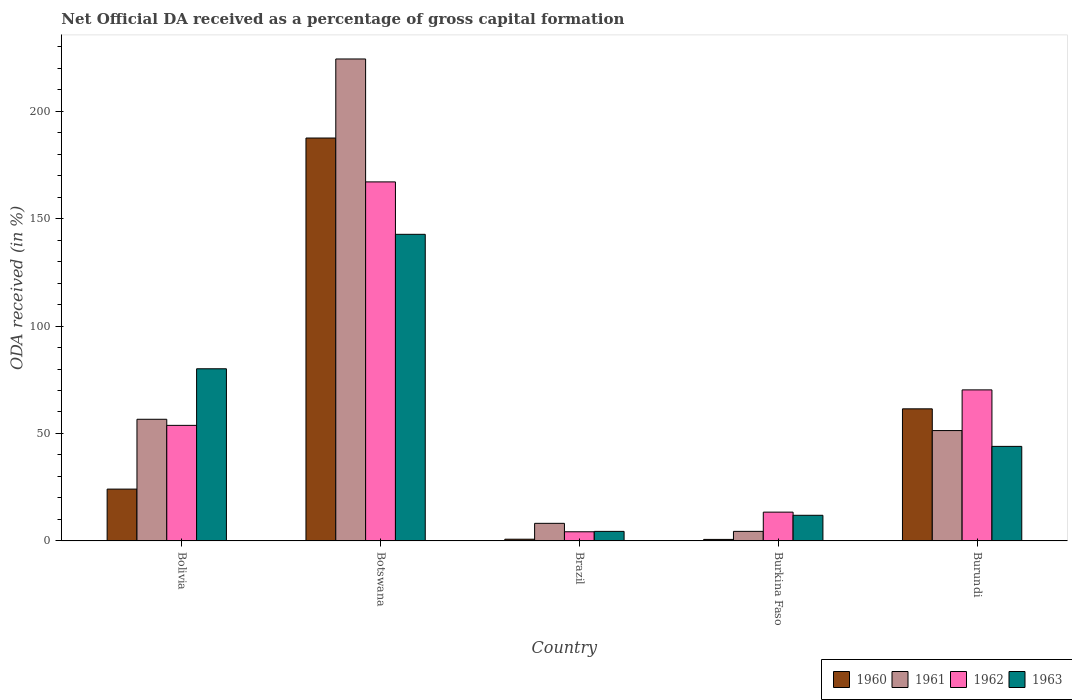How many bars are there on the 3rd tick from the left?
Offer a terse response. 4. How many bars are there on the 2nd tick from the right?
Provide a short and direct response. 4. In how many cases, is the number of bars for a given country not equal to the number of legend labels?
Provide a short and direct response. 0. What is the net ODA received in 1963 in Burkina Faso?
Give a very brief answer. 11.94. Across all countries, what is the maximum net ODA received in 1961?
Offer a very short reply. 224.27. Across all countries, what is the minimum net ODA received in 1961?
Give a very brief answer. 4.45. In which country was the net ODA received in 1963 maximum?
Provide a succinct answer. Botswana. In which country was the net ODA received in 1960 minimum?
Provide a succinct answer. Burkina Faso. What is the total net ODA received in 1961 in the graph?
Your answer should be compact. 344.89. What is the difference between the net ODA received in 1963 in Bolivia and that in Botswana?
Your answer should be compact. -62.56. What is the difference between the net ODA received in 1963 in Brazil and the net ODA received in 1961 in Botswana?
Make the answer very short. -219.82. What is the average net ODA received in 1963 per country?
Make the answer very short. 56.64. What is the difference between the net ODA received of/in 1962 and net ODA received of/in 1961 in Bolivia?
Ensure brevity in your answer.  -2.84. In how many countries, is the net ODA received in 1960 greater than 130 %?
Offer a very short reply. 1. What is the ratio of the net ODA received in 1960 in Brazil to that in Burundi?
Your response must be concise. 0.01. Is the difference between the net ODA received in 1962 in Botswana and Burkina Faso greater than the difference between the net ODA received in 1961 in Botswana and Burkina Faso?
Keep it short and to the point. No. What is the difference between the highest and the second highest net ODA received in 1963?
Offer a terse response. 36.11. What is the difference between the highest and the lowest net ODA received in 1962?
Your response must be concise. 162.81. Is it the case that in every country, the sum of the net ODA received in 1961 and net ODA received in 1963 is greater than the sum of net ODA received in 1962 and net ODA received in 1960?
Offer a very short reply. No. What does the 3rd bar from the left in Burkina Faso represents?
Provide a short and direct response. 1962. How many bars are there?
Your answer should be compact. 20. Are all the bars in the graph horizontal?
Keep it short and to the point. No. How many countries are there in the graph?
Your answer should be compact. 5. Where does the legend appear in the graph?
Make the answer very short. Bottom right. How many legend labels are there?
Provide a short and direct response. 4. How are the legend labels stacked?
Keep it short and to the point. Horizontal. What is the title of the graph?
Your response must be concise. Net Official DA received as a percentage of gross capital formation. Does "1966" appear as one of the legend labels in the graph?
Offer a terse response. No. What is the label or title of the Y-axis?
Your answer should be very brief. ODA received (in %). What is the ODA received (in %) in 1960 in Bolivia?
Keep it short and to the point. 24.12. What is the ODA received (in %) in 1961 in Bolivia?
Offer a terse response. 56.62. What is the ODA received (in %) in 1962 in Bolivia?
Provide a succinct answer. 53.77. What is the ODA received (in %) in 1963 in Bolivia?
Your answer should be very brief. 80.11. What is the ODA received (in %) of 1960 in Botswana?
Offer a terse response. 187.49. What is the ODA received (in %) of 1961 in Botswana?
Your response must be concise. 224.27. What is the ODA received (in %) of 1962 in Botswana?
Offer a very short reply. 167.07. What is the ODA received (in %) of 1963 in Botswana?
Give a very brief answer. 142.68. What is the ODA received (in %) of 1960 in Brazil?
Your answer should be compact. 0.81. What is the ODA received (in %) in 1961 in Brazil?
Your answer should be very brief. 8.19. What is the ODA received (in %) of 1962 in Brazil?
Provide a succinct answer. 4.26. What is the ODA received (in %) of 1963 in Brazil?
Your answer should be very brief. 4.45. What is the ODA received (in %) of 1960 in Burkina Faso?
Ensure brevity in your answer.  0.71. What is the ODA received (in %) in 1961 in Burkina Faso?
Ensure brevity in your answer.  4.45. What is the ODA received (in %) in 1962 in Burkina Faso?
Your response must be concise. 13.4. What is the ODA received (in %) of 1963 in Burkina Faso?
Provide a succinct answer. 11.94. What is the ODA received (in %) of 1960 in Burundi?
Make the answer very short. 61.47. What is the ODA received (in %) of 1961 in Burundi?
Offer a terse response. 51.36. What is the ODA received (in %) in 1962 in Burundi?
Offer a terse response. 70.29. Across all countries, what is the maximum ODA received (in %) in 1960?
Your response must be concise. 187.49. Across all countries, what is the maximum ODA received (in %) of 1961?
Your answer should be very brief. 224.27. Across all countries, what is the maximum ODA received (in %) of 1962?
Provide a short and direct response. 167.07. Across all countries, what is the maximum ODA received (in %) in 1963?
Your answer should be compact. 142.68. Across all countries, what is the minimum ODA received (in %) of 1960?
Offer a very short reply. 0.71. Across all countries, what is the minimum ODA received (in %) of 1961?
Give a very brief answer. 4.45. Across all countries, what is the minimum ODA received (in %) of 1962?
Provide a short and direct response. 4.26. Across all countries, what is the minimum ODA received (in %) in 1963?
Your answer should be very brief. 4.45. What is the total ODA received (in %) of 1960 in the graph?
Offer a very short reply. 274.59. What is the total ODA received (in %) of 1961 in the graph?
Offer a very short reply. 344.89. What is the total ODA received (in %) of 1962 in the graph?
Provide a succinct answer. 308.8. What is the total ODA received (in %) of 1963 in the graph?
Provide a short and direct response. 283.18. What is the difference between the ODA received (in %) of 1960 in Bolivia and that in Botswana?
Ensure brevity in your answer.  -163.37. What is the difference between the ODA received (in %) of 1961 in Bolivia and that in Botswana?
Offer a terse response. -167.65. What is the difference between the ODA received (in %) in 1962 in Bolivia and that in Botswana?
Make the answer very short. -113.3. What is the difference between the ODA received (in %) of 1963 in Bolivia and that in Botswana?
Provide a short and direct response. -62.56. What is the difference between the ODA received (in %) in 1960 in Bolivia and that in Brazil?
Ensure brevity in your answer.  23.31. What is the difference between the ODA received (in %) in 1961 in Bolivia and that in Brazil?
Make the answer very short. 48.42. What is the difference between the ODA received (in %) in 1962 in Bolivia and that in Brazil?
Give a very brief answer. 49.51. What is the difference between the ODA received (in %) of 1963 in Bolivia and that in Brazil?
Your answer should be very brief. 75.67. What is the difference between the ODA received (in %) of 1960 in Bolivia and that in Burkina Faso?
Offer a terse response. 23.41. What is the difference between the ODA received (in %) of 1961 in Bolivia and that in Burkina Faso?
Provide a succinct answer. 52.16. What is the difference between the ODA received (in %) in 1962 in Bolivia and that in Burkina Faso?
Keep it short and to the point. 40.37. What is the difference between the ODA received (in %) of 1963 in Bolivia and that in Burkina Faso?
Give a very brief answer. 68.18. What is the difference between the ODA received (in %) in 1960 in Bolivia and that in Burundi?
Make the answer very short. -37.35. What is the difference between the ODA received (in %) in 1961 in Bolivia and that in Burundi?
Give a very brief answer. 5.26. What is the difference between the ODA received (in %) in 1962 in Bolivia and that in Burundi?
Your answer should be very brief. -16.51. What is the difference between the ODA received (in %) in 1963 in Bolivia and that in Burundi?
Your answer should be compact. 36.11. What is the difference between the ODA received (in %) in 1960 in Botswana and that in Brazil?
Give a very brief answer. 186.68. What is the difference between the ODA received (in %) of 1961 in Botswana and that in Brazil?
Provide a succinct answer. 216.07. What is the difference between the ODA received (in %) of 1962 in Botswana and that in Brazil?
Give a very brief answer. 162.81. What is the difference between the ODA received (in %) in 1963 in Botswana and that in Brazil?
Ensure brevity in your answer.  138.23. What is the difference between the ODA received (in %) of 1960 in Botswana and that in Burkina Faso?
Make the answer very short. 186.78. What is the difference between the ODA received (in %) in 1961 in Botswana and that in Burkina Faso?
Keep it short and to the point. 219.81. What is the difference between the ODA received (in %) in 1962 in Botswana and that in Burkina Faso?
Provide a succinct answer. 153.67. What is the difference between the ODA received (in %) in 1963 in Botswana and that in Burkina Faso?
Offer a very short reply. 130.74. What is the difference between the ODA received (in %) in 1960 in Botswana and that in Burundi?
Keep it short and to the point. 126.02. What is the difference between the ODA received (in %) of 1961 in Botswana and that in Burundi?
Give a very brief answer. 172.91. What is the difference between the ODA received (in %) of 1962 in Botswana and that in Burundi?
Offer a very short reply. 96.78. What is the difference between the ODA received (in %) of 1963 in Botswana and that in Burundi?
Give a very brief answer. 98.68. What is the difference between the ODA received (in %) in 1960 in Brazil and that in Burkina Faso?
Provide a short and direct response. 0.1. What is the difference between the ODA received (in %) of 1961 in Brazil and that in Burkina Faso?
Ensure brevity in your answer.  3.74. What is the difference between the ODA received (in %) in 1962 in Brazil and that in Burkina Faso?
Your response must be concise. -9.14. What is the difference between the ODA received (in %) in 1963 in Brazil and that in Burkina Faso?
Your response must be concise. -7.49. What is the difference between the ODA received (in %) of 1960 in Brazil and that in Burundi?
Your answer should be compact. -60.66. What is the difference between the ODA received (in %) of 1961 in Brazil and that in Burundi?
Keep it short and to the point. -43.17. What is the difference between the ODA received (in %) in 1962 in Brazil and that in Burundi?
Provide a succinct answer. -66.02. What is the difference between the ODA received (in %) of 1963 in Brazil and that in Burundi?
Your response must be concise. -39.55. What is the difference between the ODA received (in %) in 1960 in Burkina Faso and that in Burundi?
Keep it short and to the point. -60.76. What is the difference between the ODA received (in %) in 1961 in Burkina Faso and that in Burundi?
Give a very brief answer. -46.9. What is the difference between the ODA received (in %) in 1962 in Burkina Faso and that in Burundi?
Make the answer very short. -56.88. What is the difference between the ODA received (in %) of 1963 in Burkina Faso and that in Burundi?
Your answer should be very brief. -32.06. What is the difference between the ODA received (in %) in 1960 in Bolivia and the ODA received (in %) in 1961 in Botswana?
Offer a very short reply. -200.15. What is the difference between the ODA received (in %) of 1960 in Bolivia and the ODA received (in %) of 1962 in Botswana?
Your response must be concise. -142.95. What is the difference between the ODA received (in %) of 1960 in Bolivia and the ODA received (in %) of 1963 in Botswana?
Give a very brief answer. -118.56. What is the difference between the ODA received (in %) of 1961 in Bolivia and the ODA received (in %) of 1962 in Botswana?
Provide a short and direct response. -110.45. What is the difference between the ODA received (in %) of 1961 in Bolivia and the ODA received (in %) of 1963 in Botswana?
Your answer should be very brief. -86.06. What is the difference between the ODA received (in %) of 1962 in Bolivia and the ODA received (in %) of 1963 in Botswana?
Offer a terse response. -88.9. What is the difference between the ODA received (in %) of 1960 in Bolivia and the ODA received (in %) of 1961 in Brazil?
Ensure brevity in your answer.  15.93. What is the difference between the ODA received (in %) in 1960 in Bolivia and the ODA received (in %) in 1962 in Brazil?
Offer a terse response. 19.86. What is the difference between the ODA received (in %) of 1960 in Bolivia and the ODA received (in %) of 1963 in Brazil?
Ensure brevity in your answer.  19.67. What is the difference between the ODA received (in %) in 1961 in Bolivia and the ODA received (in %) in 1962 in Brazil?
Provide a succinct answer. 52.35. What is the difference between the ODA received (in %) of 1961 in Bolivia and the ODA received (in %) of 1963 in Brazil?
Make the answer very short. 52.17. What is the difference between the ODA received (in %) of 1962 in Bolivia and the ODA received (in %) of 1963 in Brazil?
Ensure brevity in your answer.  49.33. What is the difference between the ODA received (in %) in 1960 in Bolivia and the ODA received (in %) in 1961 in Burkina Faso?
Your answer should be very brief. 19.67. What is the difference between the ODA received (in %) of 1960 in Bolivia and the ODA received (in %) of 1962 in Burkina Faso?
Your answer should be compact. 10.72. What is the difference between the ODA received (in %) in 1960 in Bolivia and the ODA received (in %) in 1963 in Burkina Faso?
Offer a terse response. 12.18. What is the difference between the ODA received (in %) in 1961 in Bolivia and the ODA received (in %) in 1962 in Burkina Faso?
Provide a succinct answer. 43.21. What is the difference between the ODA received (in %) in 1961 in Bolivia and the ODA received (in %) in 1963 in Burkina Faso?
Your response must be concise. 44.68. What is the difference between the ODA received (in %) of 1962 in Bolivia and the ODA received (in %) of 1963 in Burkina Faso?
Ensure brevity in your answer.  41.84. What is the difference between the ODA received (in %) in 1960 in Bolivia and the ODA received (in %) in 1961 in Burundi?
Provide a short and direct response. -27.24. What is the difference between the ODA received (in %) of 1960 in Bolivia and the ODA received (in %) of 1962 in Burundi?
Your answer should be very brief. -46.17. What is the difference between the ODA received (in %) of 1960 in Bolivia and the ODA received (in %) of 1963 in Burundi?
Keep it short and to the point. -19.88. What is the difference between the ODA received (in %) in 1961 in Bolivia and the ODA received (in %) in 1962 in Burundi?
Provide a succinct answer. -13.67. What is the difference between the ODA received (in %) of 1961 in Bolivia and the ODA received (in %) of 1963 in Burundi?
Provide a succinct answer. 12.62. What is the difference between the ODA received (in %) of 1962 in Bolivia and the ODA received (in %) of 1963 in Burundi?
Make the answer very short. 9.77. What is the difference between the ODA received (in %) in 1960 in Botswana and the ODA received (in %) in 1961 in Brazil?
Provide a short and direct response. 179.29. What is the difference between the ODA received (in %) of 1960 in Botswana and the ODA received (in %) of 1962 in Brazil?
Your response must be concise. 183.22. What is the difference between the ODA received (in %) of 1960 in Botswana and the ODA received (in %) of 1963 in Brazil?
Offer a very short reply. 183.04. What is the difference between the ODA received (in %) of 1961 in Botswana and the ODA received (in %) of 1962 in Brazil?
Offer a very short reply. 220. What is the difference between the ODA received (in %) of 1961 in Botswana and the ODA received (in %) of 1963 in Brazil?
Your response must be concise. 219.82. What is the difference between the ODA received (in %) in 1962 in Botswana and the ODA received (in %) in 1963 in Brazil?
Offer a very short reply. 162.62. What is the difference between the ODA received (in %) in 1960 in Botswana and the ODA received (in %) in 1961 in Burkina Faso?
Ensure brevity in your answer.  183.03. What is the difference between the ODA received (in %) in 1960 in Botswana and the ODA received (in %) in 1962 in Burkina Faso?
Ensure brevity in your answer.  174.08. What is the difference between the ODA received (in %) in 1960 in Botswana and the ODA received (in %) in 1963 in Burkina Faso?
Provide a succinct answer. 175.55. What is the difference between the ODA received (in %) in 1961 in Botswana and the ODA received (in %) in 1962 in Burkina Faso?
Give a very brief answer. 210.86. What is the difference between the ODA received (in %) in 1961 in Botswana and the ODA received (in %) in 1963 in Burkina Faso?
Offer a very short reply. 212.33. What is the difference between the ODA received (in %) of 1962 in Botswana and the ODA received (in %) of 1963 in Burkina Faso?
Offer a very short reply. 155.13. What is the difference between the ODA received (in %) of 1960 in Botswana and the ODA received (in %) of 1961 in Burundi?
Offer a terse response. 136.13. What is the difference between the ODA received (in %) in 1960 in Botswana and the ODA received (in %) in 1962 in Burundi?
Offer a terse response. 117.2. What is the difference between the ODA received (in %) of 1960 in Botswana and the ODA received (in %) of 1963 in Burundi?
Ensure brevity in your answer.  143.49. What is the difference between the ODA received (in %) in 1961 in Botswana and the ODA received (in %) in 1962 in Burundi?
Provide a short and direct response. 153.98. What is the difference between the ODA received (in %) of 1961 in Botswana and the ODA received (in %) of 1963 in Burundi?
Provide a succinct answer. 180.27. What is the difference between the ODA received (in %) of 1962 in Botswana and the ODA received (in %) of 1963 in Burundi?
Make the answer very short. 123.07. What is the difference between the ODA received (in %) of 1960 in Brazil and the ODA received (in %) of 1961 in Burkina Faso?
Ensure brevity in your answer.  -3.65. What is the difference between the ODA received (in %) in 1960 in Brazil and the ODA received (in %) in 1962 in Burkina Faso?
Give a very brief answer. -12.6. What is the difference between the ODA received (in %) of 1960 in Brazil and the ODA received (in %) of 1963 in Burkina Faso?
Offer a very short reply. -11.13. What is the difference between the ODA received (in %) in 1961 in Brazil and the ODA received (in %) in 1962 in Burkina Faso?
Offer a very short reply. -5.21. What is the difference between the ODA received (in %) in 1961 in Brazil and the ODA received (in %) in 1963 in Burkina Faso?
Offer a very short reply. -3.75. What is the difference between the ODA received (in %) of 1962 in Brazil and the ODA received (in %) of 1963 in Burkina Faso?
Ensure brevity in your answer.  -7.67. What is the difference between the ODA received (in %) in 1960 in Brazil and the ODA received (in %) in 1961 in Burundi?
Offer a very short reply. -50.55. What is the difference between the ODA received (in %) in 1960 in Brazil and the ODA received (in %) in 1962 in Burundi?
Offer a terse response. -69.48. What is the difference between the ODA received (in %) of 1960 in Brazil and the ODA received (in %) of 1963 in Burundi?
Your answer should be compact. -43.19. What is the difference between the ODA received (in %) of 1961 in Brazil and the ODA received (in %) of 1962 in Burundi?
Provide a succinct answer. -62.09. What is the difference between the ODA received (in %) of 1961 in Brazil and the ODA received (in %) of 1963 in Burundi?
Provide a short and direct response. -35.81. What is the difference between the ODA received (in %) of 1962 in Brazil and the ODA received (in %) of 1963 in Burundi?
Make the answer very short. -39.74. What is the difference between the ODA received (in %) of 1960 in Burkina Faso and the ODA received (in %) of 1961 in Burundi?
Offer a terse response. -50.65. What is the difference between the ODA received (in %) of 1960 in Burkina Faso and the ODA received (in %) of 1962 in Burundi?
Your answer should be very brief. -69.58. What is the difference between the ODA received (in %) in 1960 in Burkina Faso and the ODA received (in %) in 1963 in Burundi?
Offer a very short reply. -43.29. What is the difference between the ODA received (in %) of 1961 in Burkina Faso and the ODA received (in %) of 1962 in Burundi?
Provide a succinct answer. -65.83. What is the difference between the ODA received (in %) in 1961 in Burkina Faso and the ODA received (in %) in 1963 in Burundi?
Ensure brevity in your answer.  -39.55. What is the difference between the ODA received (in %) of 1962 in Burkina Faso and the ODA received (in %) of 1963 in Burundi?
Your response must be concise. -30.6. What is the average ODA received (in %) in 1960 per country?
Offer a very short reply. 54.92. What is the average ODA received (in %) of 1961 per country?
Give a very brief answer. 68.98. What is the average ODA received (in %) of 1962 per country?
Ensure brevity in your answer.  61.76. What is the average ODA received (in %) of 1963 per country?
Offer a very short reply. 56.64. What is the difference between the ODA received (in %) of 1960 and ODA received (in %) of 1961 in Bolivia?
Provide a succinct answer. -32.5. What is the difference between the ODA received (in %) in 1960 and ODA received (in %) in 1962 in Bolivia?
Make the answer very short. -29.66. What is the difference between the ODA received (in %) in 1960 and ODA received (in %) in 1963 in Bolivia?
Provide a short and direct response. -56. What is the difference between the ODA received (in %) of 1961 and ODA received (in %) of 1962 in Bolivia?
Give a very brief answer. 2.84. What is the difference between the ODA received (in %) of 1961 and ODA received (in %) of 1963 in Bolivia?
Ensure brevity in your answer.  -23.5. What is the difference between the ODA received (in %) of 1962 and ODA received (in %) of 1963 in Bolivia?
Provide a succinct answer. -26.34. What is the difference between the ODA received (in %) of 1960 and ODA received (in %) of 1961 in Botswana?
Your answer should be very brief. -36.78. What is the difference between the ODA received (in %) in 1960 and ODA received (in %) in 1962 in Botswana?
Offer a terse response. 20.42. What is the difference between the ODA received (in %) of 1960 and ODA received (in %) of 1963 in Botswana?
Your answer should be compact. 44.81. What is the difference between the ODA received (in %) in 1961 and ODA received (in %) in 1962 in Botswana?
Provide a succinct answer. 57.2. What is the difference between the ODA received (in %) in 1961 and ODA received (in %) in 1963 in Botswana?
Give a very brief answer. 81.59. What is the difference between the ODA received (in %) of 1962 and ODA received (in %) of 1963 in Botswana?
Offer a very short reply. 24.39. What is the difference between the ODA received (in %) of 1960 and ODA received (in %) of 1961 in Brazil?
Your response must be concise. -7.38. What is the difference between the ODA received (in %) of 1960 and ODA received (in %) of 1962 in Brazil?
Your response must be concise. -3.46. What is the difference between the ODA received (in %) of 1960 and ODA received (in %) of 1963 in Brazil?
Your answer should be very brief. -3.64. What is the difference between the ODA received (in %) in 1961 and ODA received (in %) in 1962 in Brazil?
Make the answer very short. 3.93. What is the difference between the ODA received (in %) in 1961 and ODA received (in %) in 1963 in Brazil?
Your response must be concise. 3.74. What is the difference between the ODA received (in %) in 1962 and ODA received (in %) in 1963 in Brazil?
Give a very brief answer. -0.18. What is the difference between the ODA received (in %) of 1960 and ODA received (in %) of 1961 in Burkina Faso?
Ensure brevity in your answer.  -3.74. What is the difference between the ODA received (in %) of 1960 and ODA received (in %) of 1962 in Burkina Faso?
Provide a succinct answer. -12.69. What is the difference between the ODA received (in %) in 1960 and ODA received (in %) in 1963 in Burkina Faso?
Provide a short and direct response. -11.23. What is the difference between the ODA received (in %) of 1961 and ODA received (in %) of 1962 in Burkina Faso?
Provide a succinct answer. -8.95. What is the difference between the ODA received (in %) of 1961 and ODA received (in %) of 1963 in Burkina Faso?
Make the answer very short. -7.48. What is the difference between the ODA received (in %) in 1962 and ODA received (in %) in 1963 in Burkina Faso?
Your answer should be very brief. 1.47. What is the difference between the ODA received (in %) of 1960 and ODA received (in %) of 1961 in Burundi?
Your answer should be compact. 10.11. What is the difference between the ODA received (in %) of 1960 and ODA received (in %) of 1962 in Burundi?
Make the answer very short. -8.82. What is the difference between the ODA received (in %) in 1960 and ODA received (in %) in 1963 in Burundi?
Offer a very short reply. 17.47. What is the difference between the ODA received (in %) in 1961 and ODA received (in %) in 1962 in Burundi?
Your response must be concise. -18.93. What is the difference between the ODA received (in %) of 1961 and ODA received (in %) of 1963 in Burundi?
Provide a short and direct response. 7.36. What is the difference between the ODA received (in %) in 1962 and ODA received (in %) in 1963 in Burundi?
Offer a very short reply. 26.29. What is the ratio of the ODA received (in %) of 1960 in Bolivia to that in Botswana?
Ensure brevity in your answer.  0.13. What is the ratio of the ODA received (in %) in 1961 in Bolivia to that in Botswana?
Give a very brief answer. 0.25. What is the ratio of the ODA received (in %) of 1962 in Bolivia to that in Botswana?
Offer a terse response. 0.32. What is the ratio of the ODA received (in %) of 1963 in Bolivia to that in Botswana?
Your answer should be compact. 0.56. What is the ratio of the ODA received (in %) in 1960 in Bolivia to that in Brazil?
Give a very brief answer. 29.85. What is the ratio of the ODA received (in %) in 1961 in Bolivia to that in Brazil?
Your answer should be very brief. 6.91. What is the ratio of the ODA received (in %) in 1962 in Bolivia to that in Brazil?
Provide a short and direct response. 12.61. What is the ratio of the ODA received (in %) in 1963 in Bolivia to that in Brazil?
Ensure brevity in your answer.  18.01. What is the ratio of the ODA received (in %) of 1960 in Bolivia to that in Burkina Faso?
Your answer should be compact. 33.95. What is the ratio of the ODA received (in %) of 1961 in Bolivia to that in Burkina Faso?
Your answer should be very brief. 12.71. What is the ratio of the ODA received (in %) of 1962 in Bolivia to that in Burkina Faso?
Offer a very short reply. 4.01. What is the ratio of the ODA received (in %) of 1963 in Bolivia to that in Burkina Faso?
Your response must be concise. 6.71. What is the ratio of the ODA received (in %) in 1960 in Bolivia to that in Burundi?
Your answer should be compact. 0.39. What is the ratio of the ODA received (in %) in 1961 in Bolivia to that in Burundi?
Your response must be concise. 1.1. What is the ratio of the ODA received (in %) in 1962 in Bolivia to that in Burundi?
Your response must be concise. 0.77. What is the ratio of the ODA received (in %) in 1963 in Bolivia to that in Burundi?
Keep it short and to the point. 1.82. What is the ratio of the ODA received (in %) of 1960 in Botswana to that in Brazil?
Your response must be concise. 232.07. What is the ratio of the ODA received (in %) of 1961 in Botswana to that in Brazil?
Offer a terse response. 27.38. What is the ratio of the ODA received (in %) in 1962 in Botswana to that in Brazil?
Provide a short and direct response. 39.18. What is the ratio of the ODA received (in %) of 1963 in Botswana to that in Brazil?
Your answer should be compact. 32.07. What is the ratio of the ODA received (in %) in 1960 in Botswana to that in Burkina Faso?
Give a very brief answer. 263.92. What is the ratio of the ODA received (in %) in 1961 in Botswana to that in Burkina Faso?
Give a very brief answer. 50.35. What is the ratio of the ODA received (in %) of 1962 in Botswana to that in Burkina Faso?
Your response must be concise. 12.46. What is the ratio of the ODA received (in %) in 1963 in Botswana to that in Burkina Faso?
Your response must be concise. 11.95. What is the ratio of the ODA received (in %) of 1960 in Botswana to that in Burundi?
Make the answer very short. 3.05. What is the ratio of the ODA received (in %) of 1961 in Botswana to that in Burundi?
Your response must be concise. 4.37. What is the ratio of the ODA received (in %) in 1962 in Botswana to that in Burundi?
Your response must be concise. 2.38. What is the ratio of the ODA received (in %) in 1963 in Botswana to that in Burundi?
Make the answer very short. 3.24. What is the ratio of the ODA received (in %) in 1960 in Brazil to that in Burkina Faso?
Ensure brevity in your answer.  1.14. What is the ratio of the ODA received (in %) in 1961 in Brazil to that in Burkina Faso?
Offer a very short reply. 1.84. What is the ratio of the ODA received (in %) of 1962 in Brazil to that in Burkina Faso?
Ensure brevity in your answer.  0.32. What is the ratio of the ODA received (in %) in 1963 in Brazil to that in Burkina Faso?
Provide a short and direct response. 0.37. What is the ratio of the ODA received (in %) of 1960 in Brazil to that in Burundi?
Give a very brief answer. 0.01. What is the ratio of the ODA received (in %) in 1961 in Brazil to that in Burundi?
Your response must be concise. 0.16. What is the ratio of the ODA received (in %) in 1962 in Brazil to that in Burundi?
Offer a very short reply. 0.06. What is the ratio of the ODA received (in %) of 1963 in Brazil to that in Burundi?
Your answer should be very brief. 0.1. What is the ratio of the ODA received (in %) in 1960 in Burkina Faso to that in Burundi?
Ensure brevity in your answer.  0.01. What is the ratio of the ODA received (in %) in 1961 in Burkina Faso to that in Burundi?
Your answer should be compact. 0.09. What is the ratio of the ODA received (in %) of 1962 in Burkina Faso to that in Burundi?
Give a very brief answer. 0.19. What is the ratio of the ODA received (in %) in 1963 in Burkina Faso to that in Burundi?
Keep it short and to the point. 0.27. What is the difference between the highest and the second highest ODA received (in %) in 1960?
Keep it short and to the point. 126.02. What is the difference between the highest and the second highest ODA received (in %) of 1961?
Make the answer very short. 167.65. What is the difference between the highest and the second highest ODA received (in %) of 1962?
Offer a terse response. 96.78. What is the difference between the highest and the second highest ODA received (in %) of 1963?
Give a very brief answer. 62.56. What is the difference between the highest and the lowest ODA received (in %) in 1960?
Your answer should be very brief. 186.78. What is the difference between the highest and the lowest ODA received (in %) in 1961?
Your response must be concise. 219.81. What is the difference between the highest and the lowest ODA received (in %) of 1962?
Provide a short and direct response. 162.81. What is the difference between the highest and the lowest ODA received (in %) in 1963?
Your answer should be compact. 138.23. 